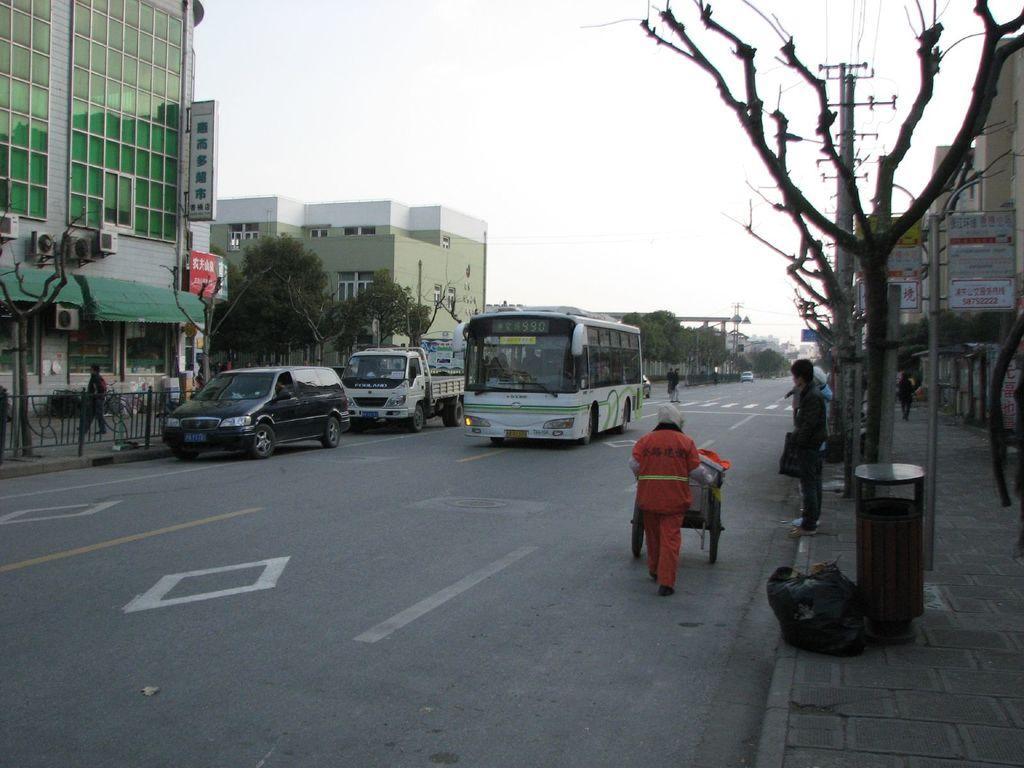How would you summarize this image in a sentence or two? In this picture there are few vehicles and persons on the road and there are few buildings and trees in the background and there are few poles,trees which has no leaves on it and a building in the right corner. 